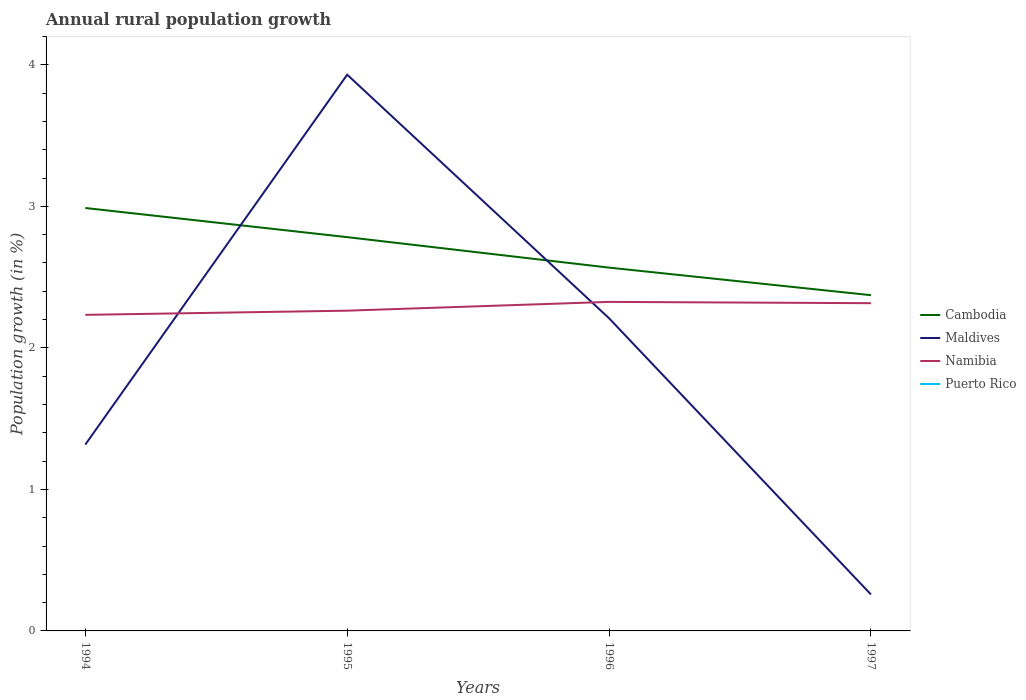Is the number of lines equal to the number of legend labels?
Give a very brief answer. No. Across all years, what is the maximum percentage of rural population growth in Maldives?
Ensure brevity in your answer.  0.26. What is the total percentage of rural population growth in Cambodia in the graph?
Your answer should be compact. 0.21. What is the difference between the highest and the second highest percentage of rural population growth in Cambodia?
Your answer should be very brief. 0.62. What is the difference between the highest and the lowest percentage of rural population growth in Namibia?
Provide a short and direct response. 2. Is the percentage of rural population growth in Cambodia strictly greater than the percentage of rural population growth in Puerto Rico over the years?
Your answer should be very brief. No. Are the values on the major ticks of Y-axis written in scientific E-notation?
Ensure brevity in your answer.  No. Does the graph contain any zero values?
Your answer should be very brief. Yes. Does the graph contain grids?
Give a very brief answer. No. How many legend labels are there?
Provide a short and direct response. 4. How are the legend labels stacked?
Keep it short and to the point. Vertical. What is the title of the graph?
Your answer should be compact. Annual rural population growth. Does "Turks and Caicos Islands" appear as one of the legend labels in the graph?
Keep it short and to the point. No. What is the label or title of the X-axis?
Your response must be concise. Years. What is the label or title of the Y-axis?
Provide a succinct answer. Population growth (in %). What is the Population growth (in %) in Cambodia in 1994?
Ensure brevity in your answer.  2.99. What is the Population growth (in %) of Maldives in 1994?
Offer a very short reply. 1.32. What is the Population growth (in %) of Namibia in 1994?
Your response must be concise. 2.23. What is the Population growth (in %) in Puerto Rico in 1994?
Your response must be concise. 0. What is the Population growth (in %) in Cambodia in 1995?
Offer a very short reply. 2.78. What is the Population growth (in %) of Maldives in 1995?
Your answer should be compact. 3.93. What is the Population growth (in %) in Namibia in 1995?
Offer a very short reply. 2.26. What is the Population growth (in %) in Puerto Rico in 1995?
Give a very brief answer. 0. What is the Population growth (in %) in Cambodia in 1996?
Give a very brief answer. 2.57. What is the Population growth (in %) in Maldives in 1996?
Offer a terse response. 2.21. What is the Population growth (in %) in Namibia in 1996?
Give a very brief answer. 2.33. What is the Population growth (in %) of Puerto Rico in 1996?
Your answer should be very brief. 0. What is the Population growth (in %) of Cambodia in 1997?
Your answer should be compact. 2.37. What is the Population growth (in %) of Maldives in 1997?
Offer a terse response. 0.26. What is the Population growth (in %) of Namibia in 1997?
Your answer should be compact. 2.32. What is the Population growth (in %) in Puerto Rico in 1997?
Your answer should be very brief. 0. Across all years, what is the maximum Population growth (in %) of Cambodia?
Your answer should be very brief. 2.99. Across all years, what is the maximum Population growth (in %) of Maldives?
Keep it short and to the point. 3.93. Across all years, what is the maximum Population growth (in %) in Namibia?
Offer a very short reply. 2.33. Across all years, what is the minimum Population growth (in %) of Cambodia?
Ensure brevity in your answer.  2.37. Across all years, what is the minimum Population growth (in %) in Maldives?
Your answer should be compact. 0.26. Across all years, what is the minimum Population growth (in %) in Namibia?
Your answer should be very brief. 2.23. What is the total Population growth (in %) in Cambodia in the graph?
Give a very brief answer. 10.71. What is the total Population growth (in %) of Maldives in the graph?
Ensure brevity in your answer.  7.71. What is the total Population growth (in %) in Namibia in the graph?
Make the answer very short. 9.14. What is the difference between the Population growth (in %) of Cambodia in 1994 and that in 1995?
Give a very brief answer. 0.21. What is the difference between the Population growth (in %) of Maldives in 1994 and that in 1995?
Provide a short and direct response. -2.61. What is the difference between the Population growth (in %) of Namibia in 1994 and that in 1995?
Your answer should be compact. -0.03. What is the difference between the Population growth (in %) in Cambodia in 1994 and that in 1996?
Ensure brevity in your answer.  0.42. What is the difference between the Population growth (in %) of Maldives in 1994 and that in 1996?
Ensure brevity in your answer.  -0.89. What is the difference between the Population growth (in %) of Namibia in 1994 and that in 1996?
Offer a very short reply. -0.09. What is the difference between the Population growth (in %) of Cambodia in 1994 and that in 1997?
Keep it short and to the point. 0.62. What is the difference between the Population growth (in %) of Maldives in 1994 and that in 1997?
Offer a very short reply. 1.06. What is the difference between the Population growth (in %) of Namibia in 1994 and that in 1997?
Your response must be concise. -0.08. What is the difference between the Population growth (in %) in Cambodia in 1995 and that in 1996?
Make the answer very short. 0.22. What is the difference between the Population growth (in %) in Maldives in 1995 and that in 1996?
Give a very brief answer. 1.72. What is the difference between the Population growth (in %) of Namibia in 1995 and that in 1996?
Your answer should be compact. -0.06. What is the difference between the Population growth (in %) in Cambodia in 1995 and that in 1997?
Ensure brevity in your answer.  0.41. What is the difference between the Population growth (in %) in Maldives in 1995 and that in 1997?
Provide a short and direct response. 3.67. What is the difference between the Population growth (in %) of Namibia in 1995 and that in 1997?
Make the answer very short. -0.05. What is the difference between the Population growth (in %) of Cambodia in 1996 and that in 1997?
Keep it short and to the point. 0.19. What is the difference between the Population growth (in %) in Maldives in 1996 and that in 1997?
Keep it short and to the point. 1.95. What is the difference between the Population growth (in %) of Namibia in 1996 and that in 1997?
Your answer should be very brief. 0.01. What is the difference between the Population growth (in %) of Cambodia in 1994 and the Population growth (in %) of Maldives in 1995?
Make the answer very short. -0.94. What is the difference between the Population growth (in %) in Cambodia in 1994 and the Population growth (in %) in Namibia in 1995?
Provide a short and direct response. 0.73. What is the difference between the Population growth (in %) in Maldives in 1994 and the Population growth (in %) in Namibia in 1995?
Provide a short and direct response. -0.95. What is the difference between the Population growth (in %) of Cambodia in 1994 and the Population growth (in %) of Maldives in 1996?
Your answer should be compact. 0.78. What is the difference between the Population growth (in %) in Cambodia in 1994 and the Population growth (in %) in Namibia in 1996?
Offer a very short reply. 0.66. What is the difference between the Population growth (in %) in Maldives in 1994 and the Population growth (in %) in Namibia in 1996?
Keep it short and to the point. -1.01. What is the difference between the Population growth (in %) in Cambodia in 1994 and the Population growth (in %) in Maldives in 1997?
Provide a short and direct response. 2.73. What is the difference between the Population growth (in %) of Cambodia in 1994 and the Population growth (in %) of Namibia in 1997?
Your answer should be very brief. 0.67. What is the difference between the Population growth (in %) of Maldives in 1994 and the Population growth (in %) of Namibia in 1997?
Your answer should be very brief. -1. What is the difference between the Population growth (in %) of Cambodia in 1995 and the Population growth (in %) of Maldives in 1996?
Provide a succinct answer. 0.57. What is the difference between the Population growth (in %) in Cambodia in 1995 and the Population growth (in %) in Namibia in 1996?
Offer a very short reply. 0.46. What is the difference between the Population growth (in %) in Maldives in 1995 and the Population growth (in %) in Namibia in 1996?
Your response must be concise. 1.61. What is the difference between the Population growth (in %) in Cambodia in 1995 and the Population growth (in %) in Maldives in 1997?
Provide a succinct answer. 2.53. What is the difference between the Population growth (in %) of Cambodia in 1995 and the Population growth (in %) of Namibia in 1997?
Keep it short and to the point. 0.47. What is the difference between the Population growth (in %) in Maldives in 1995 and the Population growth (in %) in Namibia in 1997?
Offer a very short reply. 1.61. What is the difference between the Population growth (in %) in Cambodia in 1996 and the Population growth (in %) in Maldives in 1997?
Offer a terse response. 2.31. What is the difference between the Population growth (in %) in Cambodia in 1996 and the Population growth (in %) in Namibia in 1997?
Offer a terse response. 0.25. What is the difference between the Population growth (in %) in Maldives in 1996 and the Population growth (in %) in Namibia in 1997?
Your answer should be compact. -0.11. What is the average Population growth (in %) in Cambodia per year?
Offer a very short reply. 2.68. What is the average Population growth (in %) in Maldives per year?
Provide a short and direct response. 1.93. What is the average Population growth (in %) of Namibia per year?
Your answer should be compact. 2.28. In the year 1994, what is the difference between the Population growth (in %) in Cambodia and Population growth (in %) in Maldives?
Offer a very short reply. 1.67. In the year 1994, what is the difference between the Population growth (in %) in Cambodia and Population growth (in %) in Namibia?
Give a very brief answer. 0.76. In the year 1994, what is the difference between the Population growth (in %) of Maldives and Population growth (in %) of Namibia?
Your answer should be compact. -0.92. In the year 1995, what is the difference between the Population growth (in %) of Cambodia and Population growth (in %) of Maldives?
Offer a terse response. -1.15. In the year 1995, what is the difference between the Population growth (in %) in Cambodia and Population growth (in %) in Namibia?
Provide a short and direct response. 0.52. In the year 1995, what is the difference between the Population growth (in %) of Maldives and Population growth (in %) of Namibia?
Keep it short and to the point. 1.67. In the year 1996, what is the difference between the Population growth (in %) of Cambodia and Population growth (in %) of Maldives?
Provide a succinct answer. 0.36. In the year 1996, what is the difference between the Population growth (in %) of Cambodia and Population growth (in %) of Namibia?
Make the answer very short. 0.24. In the year 1996, what is the difference between the Population growth (in %) in Maldives and Population growth (in %) in Namibia?
Your answer should be very brief. -0.12. In the year 1997, what is the difference between the Population growth (in %) of Cambodia and Population growth (in %) of Maldives?
Make the answer very short. 2.12. In the year 1997, what is the difference between the Population growth (in %) in Cambodia and Population growth (in %) in Namibia?
Ensure brevity in your answer.  0.06. In the year 1997, what is the difference between the Population growth (in %) of Maldives and Population growth (in %) of Namibia?
Make the answer very short. -2.06. What is the ratio of the Population growth (in %) of Cambodia in 1994 to that in 1995?
Your answer should be very brief. 1.07. What is the ratio of the Population growth (in %) in Maldives in 1994 to that in 1995?
Provide a succinct answer. 0.34. What is the ratio of the Population growth (in %) of Namibia in 1994 to that in 1995?
Your answer should be very brief. 0.99. What is the ratio of the Population growth (in %) of Cambodia in 1994 to that in 1996?
Ensure brevity in your answer.  1.16. What is the ratio of the Population growth (in %) in Maldives in 1994 to that in 1996?
Ensure brevity in your answer.  0.6. What is the ratio of the Population growth (in %) in Namibia in 1994 to that in 1996?
Keep it short and to the point. 0.96. What is the ratio of the Population growth (in %) of Cambodia in 1994 to that in 1997?
Offer a terse response. 1.26. What is the ratio of the Population growth (in %) of Maldives in 1994 to that in 1997?
Your answer should be very brief. 5.11. What is the ratio of the Population growth (in %) of Namibia in 1994 to that in 1997?
Provide a short and direct response. 0.96. What is the ratio of the Population growth (in %) in Cambodia in 1995 to that in 1996?
Give a very brief answer. 1.08. What is the ratio of the Population growth (in %) in Maldives in 1995 to that in 1996?
Provide a succinct answer. 1.78. What is the ratio of the Population growth (in %) of Namibia in 1995 to that in 1996?
Your response must be concise. 0.97. What is the ratio of the Population growth (in %) in Cambodia in 1995 to that in 1997?
Provide a succinct answer. 1.17. What is the ratio of the Population growth (in %) of Maldives in 1995 to that in 1997?
Your response must be concise. 15.26. What is the ratio of the Population growth (in %) of Namibia in 1995 to that in 1997?
Your response must be concise. 0.98. What is the ratio of the Population growth (in %) of Cambodia in 1996 to that in 1997?
Offer a terse response. 1.08. What is the ratio of the Population growth (in %) of Maldives in 1996 to that in 1997?
Your answer should be compact. 8.58. What is the difference between the highest and the second highest Population growth (in %) of Cambodia?
Your response must be concise. 0.21. What is the difference between the highest and the second highest Population growth (in %) in Maldives?
Make the answer very short. 1.72. What is the difference between the highest and the second highest Population growth (in %) of Namibia?
Keep it short and to the point. 0.01. What is the difference between the highest and the lowest Population growth (in %) in Cambodia?
Provide a short and direct response. 0.62. What is the difference between the highest and the lowest Population growth (in %) of Maldives?
Make the answer very short. 3.67. What is the difference between the highest and the lowest Population growth (in %) in Namibia?
Give a very brief answer. 0.09. 